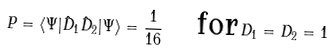Convert formula to latex. <formula><loc_0><loc_0><loc_500><loc_500>P = \langle \Psi | \hat { D } _ { 1 } \hat { D } _ { 2 } | \Psi \rangle = \frac { 1 } { 1 6 } \quad \text {for} \, D _ { 1 } = D _ { 2 } = 1</formula> 